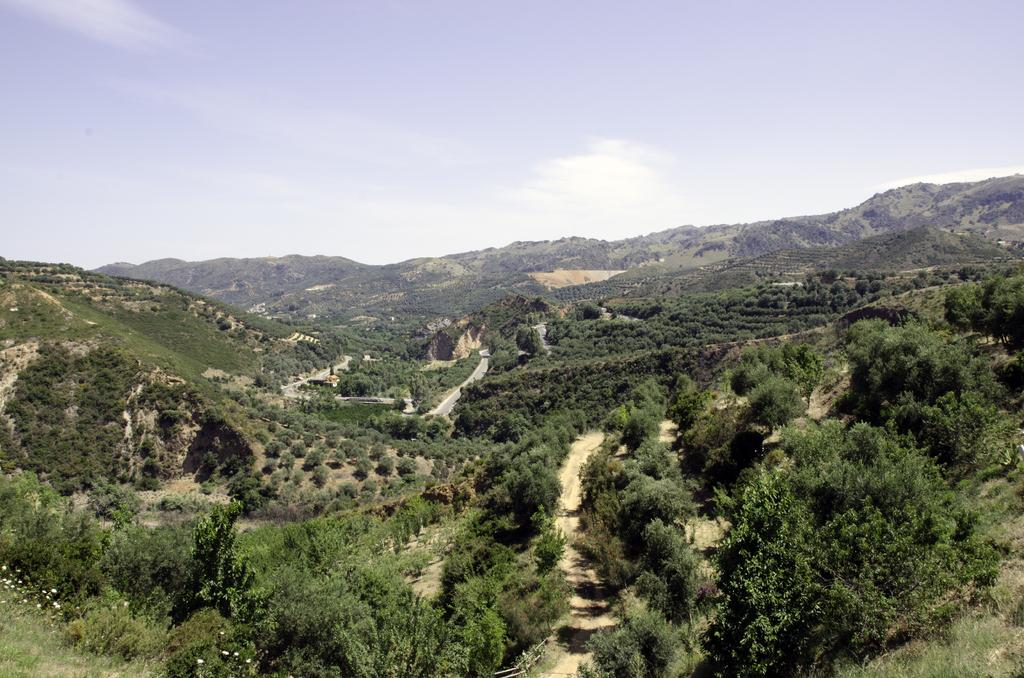What can be seen in the sky in the image? The sky with clouds is visible in the image. What type of natural features are present in the image? There are hills and trees visible in the image. What type of man-made structures can be seen in the image? Roads are present in the image. What type of grass is growing on the trees in the image? There is no grass growing on the trees in the image; trees and grass are separate entities. 